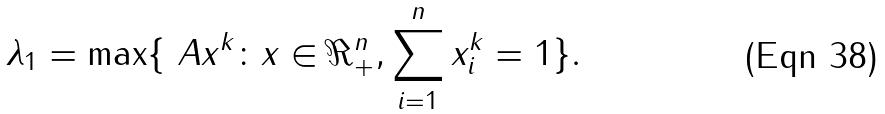<formula> <loc_0><loc_0><loc_500><loc_500>\lambda _ { 1 } = \max \{ \ A x ^ { k } \colon x \in \Re ^ { n } _ { + } , \sum _ { i = 1 } ^ { n } x _ { i } ^ { k } = 1 \} .</formula> 